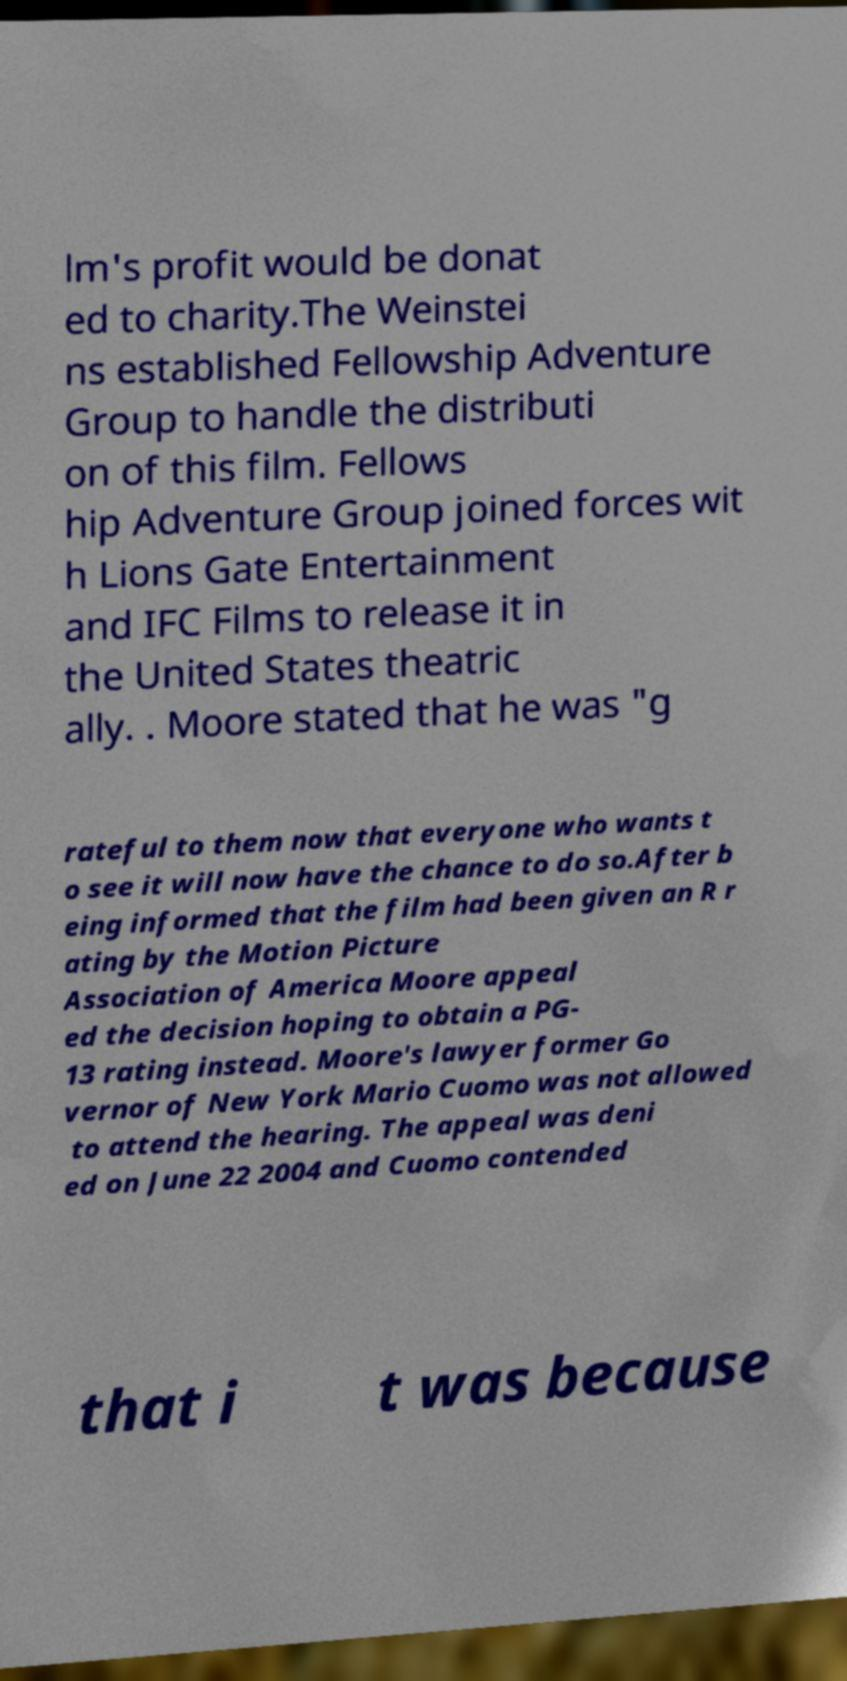I need the written content from this picture converted into text. Can you do that? lm's profit would be donat ed to charity.The Weinstei ns established Fellowship Adventure Group to handle the distributi on of this film. Fellows hip Adventure Group joined forces wit h Lions Gate Entertainment and IFC Films to release it in the United States theatric ally. . Moore stated that he was "g rateful to them now that everyone who wants t o see it will now have the chance to do so.After b eing informed that the film had been given an R r ating by the Motion Picture Association of America Moore appeal ed the decision hoping to obtain a PG- 13 rating instead. Moore's lawyer former Go vernor of New York Mario Cuomo was not allowed to attend the hearing. The appeal was deni ed on June 22 2004 and Cuomo contended that i t was because 